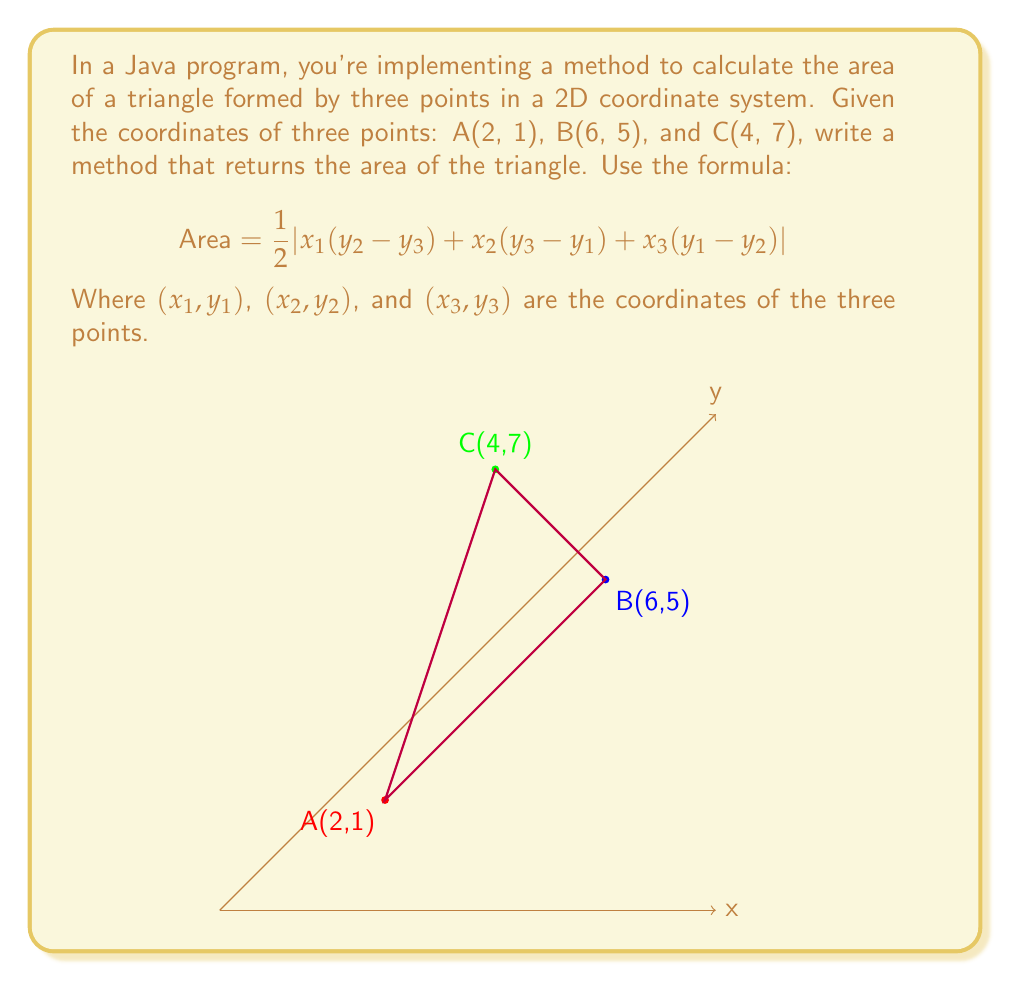Give your solution to this math problem. Let's solve this step-by-step:

1) We have the coordinates:
   A(x₁, y₁) = (2, 1)
   B(x₂, y₂) = (6, 5)
   C(x₃, y₃) = (4, 7)

2) Let's substitute these into the formula:

   $$ \text{Area} = \frac{1}{2}|x_1(y_2 - y_3) + x_2(y_3 - y_1) + x_3(y_1 - y_2)| $$

3) Substituting the values:

   $$ \text{Area} = \frac{1}{2}|2(5 - 7) + 6(7 - 1) + 4(1 - 5)| $$

4) Simplify inside the parentheses:

   $$ \text{Area} = \frac{1}{2}|2(-2) + 6(6) + 4(-4)| $$

5) Multiply:

   $$ \text{Area} = \frac{1}{2}|-4 + 36 - 16| $$

6) Add inside the absolute value signs:

   $$ \text{Area} = \frac{1}{2}|16| $$

7) The absolute value of 16 is 16:

   $$ \text{Area} = \frac{1}{2} \cdot 16 $$

8) Multiply:

   $$ \text{Area} = 8 $$

Therefore, the area of the triangle is 8 square units.
Answer: 8 square units 